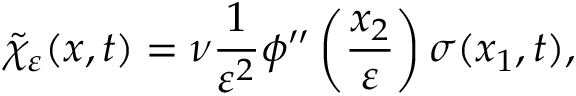Convert formula to latex. <formula><loc_0><loc_0><loc_500><loc_500>\tilde { \chi } _ { \varepsilon } ( x , t ) = \nu \frac { 1 } { \varepsilon ^ { 2 } } \phi ^ { \prime \prime } \left ( \frac { x _ { 2 } } { \varepsilon } \right ) \sigma ( x _ { 1 } , t ) ,</formula> 